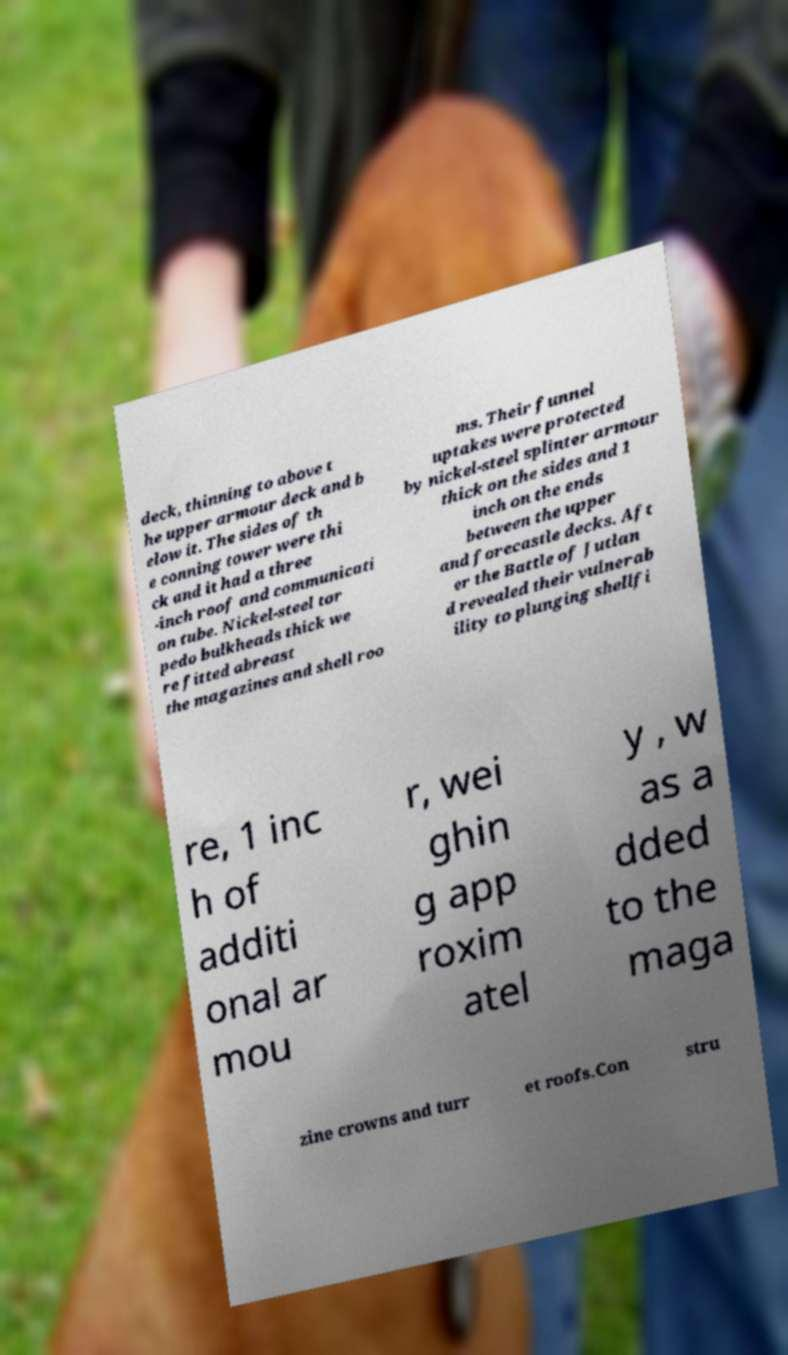Could you assist in decoding the text presented in this image and type it out clearly? deck, thinning to above t he upper armour deck and b elow it. The sides of th e conning tower were thi ck and it had a three -inch roof and communicati on tube. Nickel-steel tor pedo bulkheads thick we re fitted abreast the magazines and shell roo ms. Their funnel uptakes were protected by nickel-steel splinter armour thick on the sides and 1 inch on the ends between the upper and forecastle decks. Aft er the Battle of Jutlan d revealed their vulnerab ility to plunging shellfi re, 1 inc h of additi onal ar mou r, wei ghin g app roxim atel y , w as a dded to the maga zine crowns and turr et roofs.Con stru 